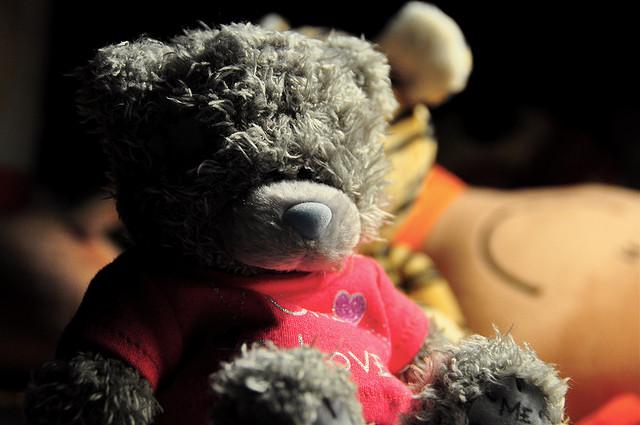Is this a live bear?
Be succinct. No. Is that tigger behind the bear?
Give a very brief answer. Yes. What is the bear wearing?
Answer briefly. Shirt. 